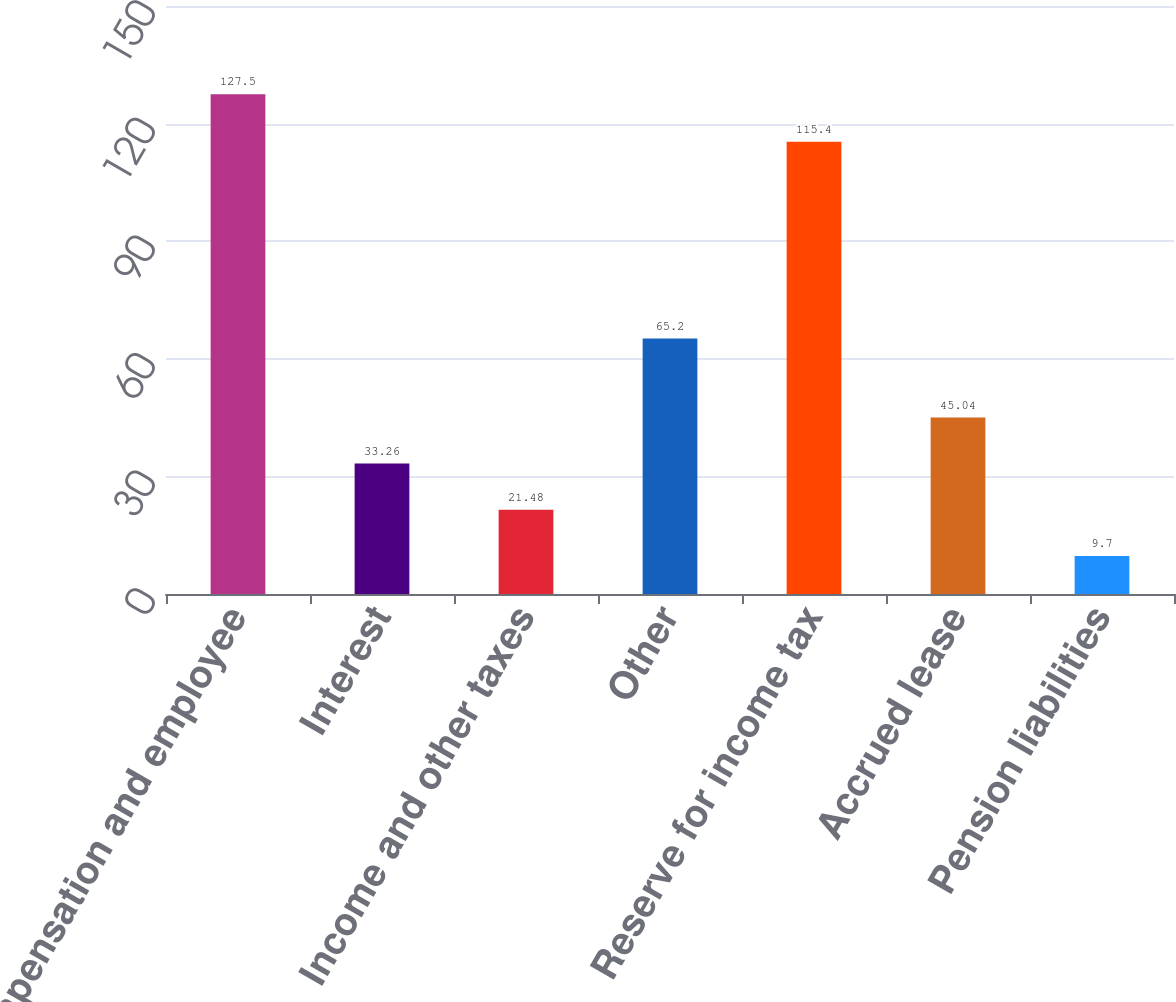Convert chart. <chart><loc_0><loc_0><loc_500><loc_500><bar_chart><fcel>Compensation and employee<fcel>Interest<fcel>Income and other taxes<fcel>Other<fcel>Reserve for income tax<fcel>Accrued lease<fcel>Pension liabilities<nl><fcel>127.5<fcel>33.26<fcel>21.48<fcel>65.2<fcel>115.4<fcel>45.04<fcel>9.7<nl></chart> 